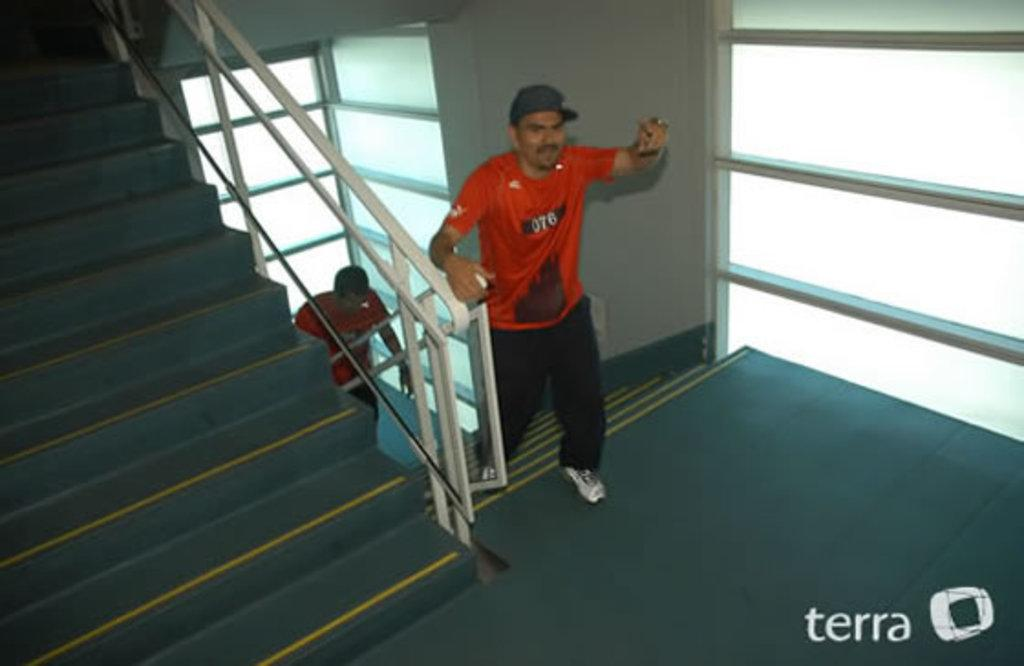How many people are in the image? There are two persons in the image. What is one of the persons wearing? One person is wearing specs. What architectural feature can be seen in the image? There are steps with railings in the image. What type of walls are present in the image? There are glass walls in the image. What type of twig is being used as a tool by the person wearing specs in the image? There is no twig present in the image, and the person wearing specs is not using any tool. What type of slavery is depicted in the image? There is no depiction of slavery in the image; it features two people and architectural elements. 